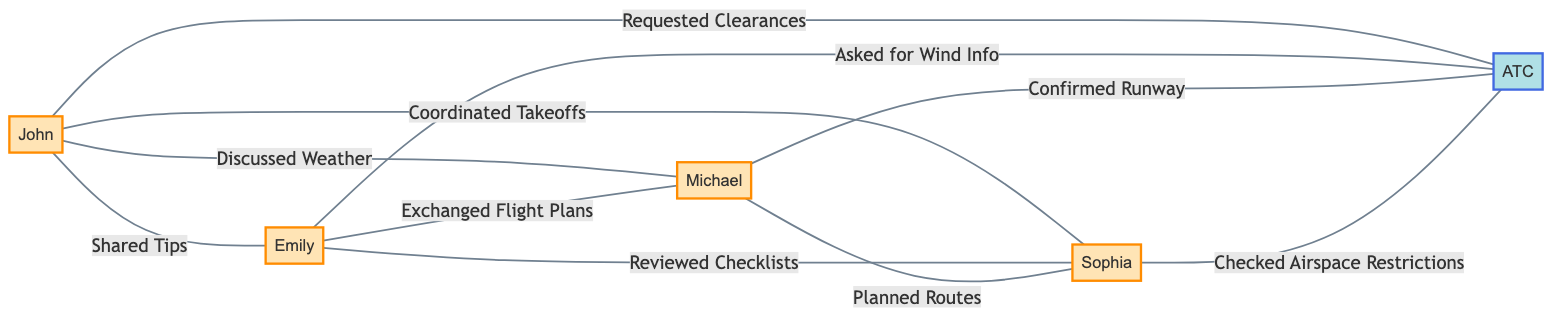What are the names of the pilots in the diagram? The diagram lists the nodes representing pilots, which include John, Emily, Michael, and Sophia. These names are taken directly from the node labels.
Answer: John, Emily, Michael, Sophia How many connections does Pilot A have? Pilot A is connected to Pilot B, Pilot C, Pilot D, and the Air Traffic Controller, making a total of four connections visible in the edges.
Answer: 4 What type of relationship exists between Pilot B and Pilot D? The edge connecting Pilot B and Pilot D is labeled "Reviewed Checklists", indicating the type of relationship. This label is seen in the visual representation of the edge.
Answer: Reviewed Checklists Which pilot confirmed the runway with the Air Traffic Controller? The edge from Pilot C to the Air Traffic Controller is labeled "Confirmed Runway". This information is identified by looking at the relationships and their labels in the graph.
Answer: Michael Who asked for wind information? The connected edge from Pilot B to the Air Traffic Controller is labeled "Asked for Wind Info", which explicitly identifies Pilot B as the one making the request.
Answer: Emily What is the total number of edges in the diagram? Counting all the connections shown in the edges section, there are a total of eight relationships linking the nodes, which represent the edges in the undirected graph.
Answer: 8 Which pilot has the most diverse set of interactions? Pilot A interacts with three other pilots and the Air Traffic Controller, leading to a broader diversity of interactions. By checking the edges, this becomes clear as they connect to four nodes, more than any other pilot.
Answer: John Is there any edge connecting Pilot C and Pilot A? The edge connecting Pilot C and Pilot A is labeled "Discussed Weather". By reviewing the edges, it's confirmed that there is a direct relationship between these two pilots.
Answer: Yes 